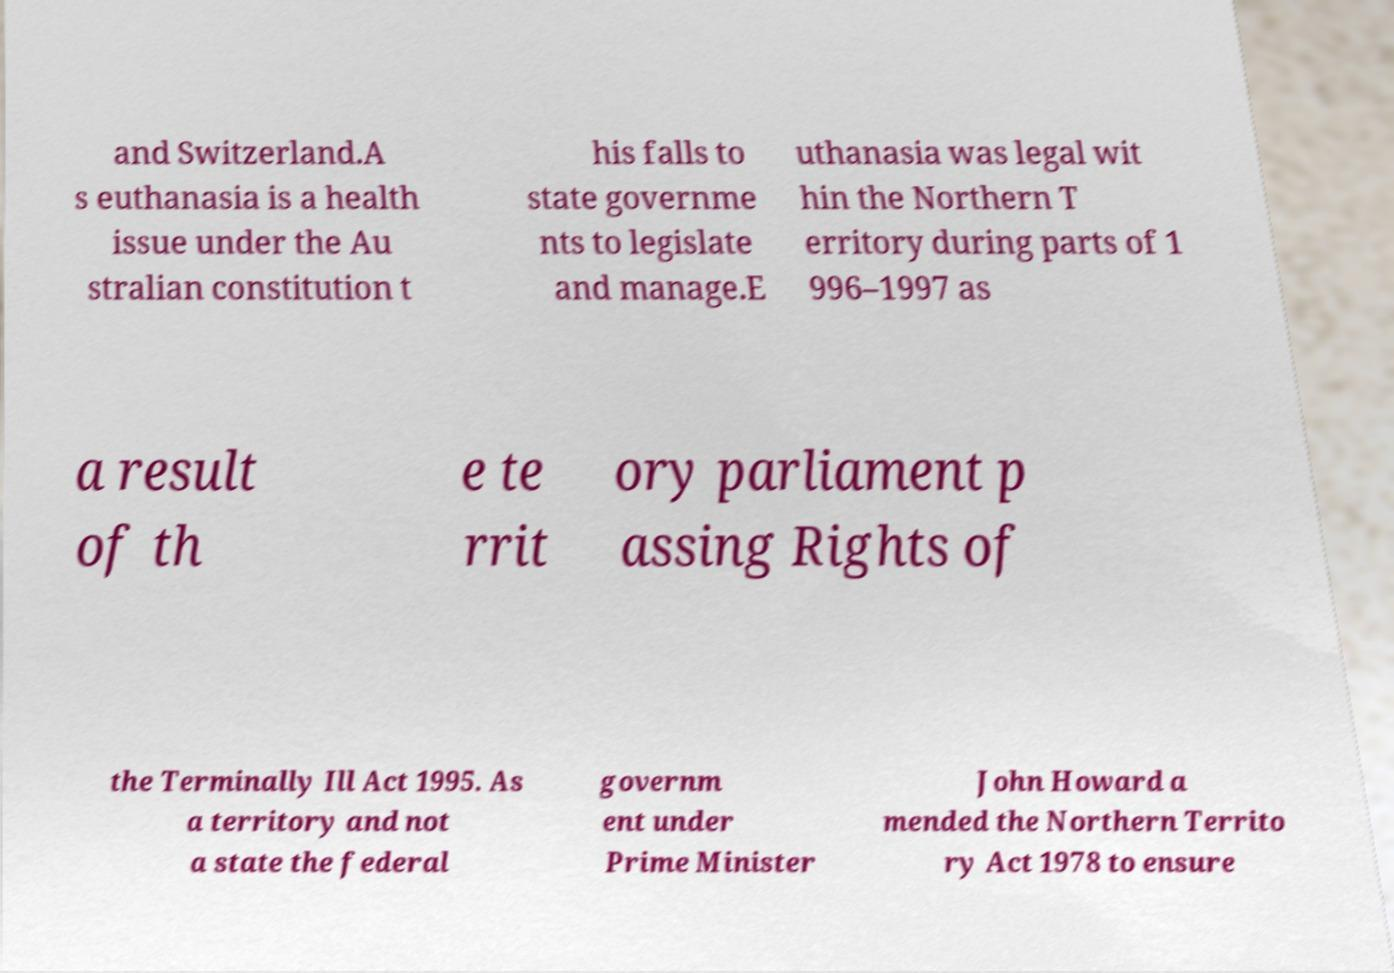Can you read and provide the text displayed in the image?This photo seems to have some interesting text. Can you extract and type it out for me? and Switzerland.A s euthanasia is a health issue under the Au stralian constitution t his falls to state governme nts to legislate and manage.E uthanasia was legal wit hin the Northern T erritory during parts of 1 996–1997 as a result of th e te rrit ory parliament p assing Rights of the Terminally Ill Act 1995. As a territory and not a state the federal governm ent under Prime Minister John Howard a mended the Northern Territo ry Act 1978 to ensure 